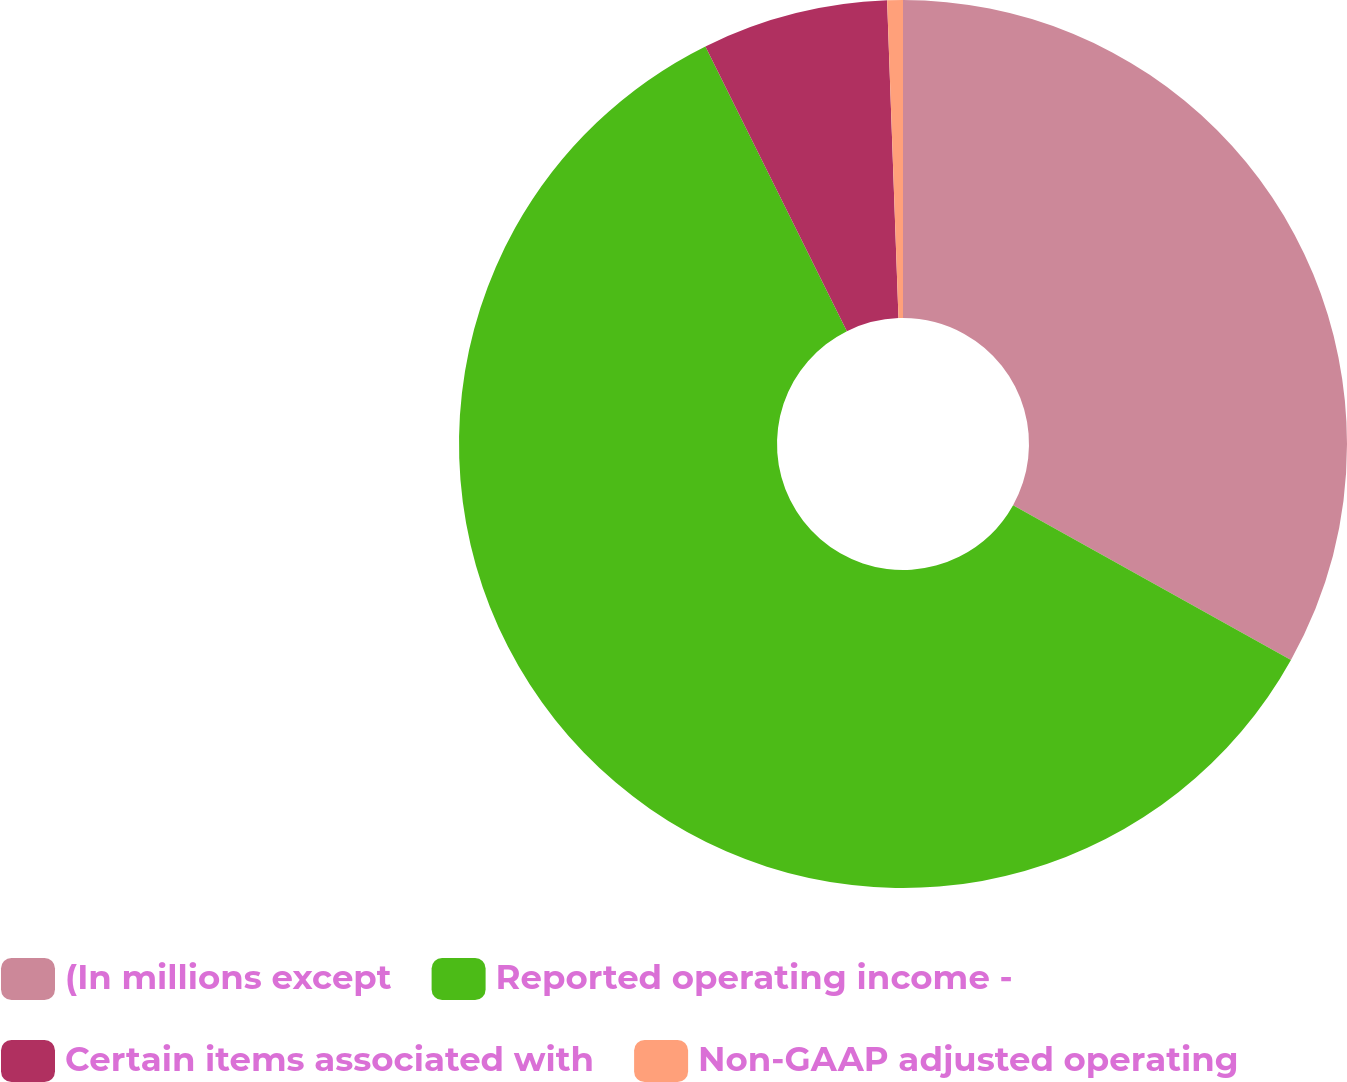<chart> <loc_0><loc_0><loc_500><loc_500><pie_chart><fcel>(In millions except<fcel>Reported operating income -<fcel>Certain items associated with<fcel>Non-GAAP adjusted operating<nl><fcel>33.08%<fcel>59.57%<fcel>6.77%<fcel>0.57%<nl></chart> 